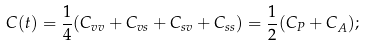Convert formula to latex. <formula><loc_0><loc_0><loc_500><loc_500>C ( t ) = \frac { 1 } { 4 } ( C _ { v v } + C _ { v s } + C _ { s v } + C _ { s s } ) = \frac { 1 } { 2 } ( C _ { P } + C _ { A } ) ;</formula> 